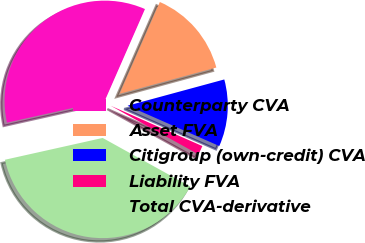Convert chart to OTSL. <chart><loc_0><loc_0><loc_500><loc_500><pie_chart><fcel>Counterparty CVA<fcel>Asset FVA<fcel>Citigroup (own-credit) CVA<fcel>Liability FVA<fcel>Total CVA-derivative<nl><fcel>35.06%<fcel>14.21%<fcel>10.81%<fcel>1.46%<fcel>38.45%<nl></chart> 